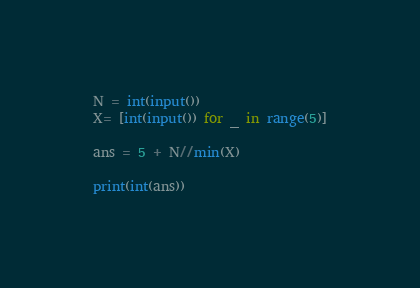<code> <loc_0><loc_0><loc_500><loc_500><_Python_>N = int(input())
X= [int(input()) for _ in range(5)]

ans = 5 + N//min(X)

print(int(ans))</code> 